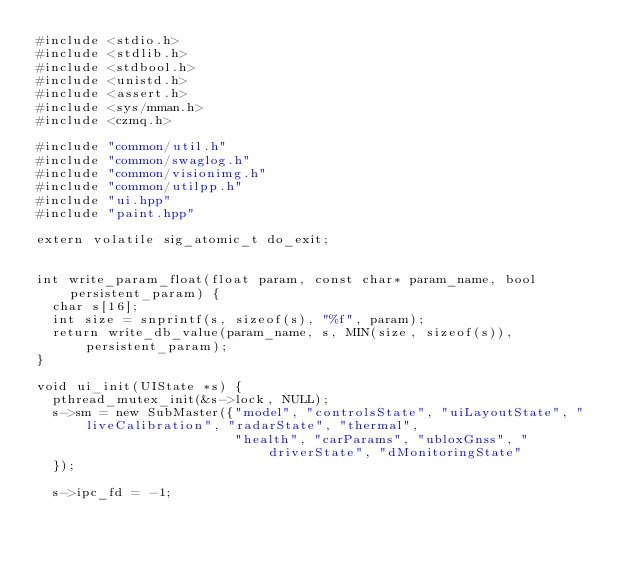<code> <loc_0><loc_0><loc_500><loc_500><_C++_>#include <stdio.h>
#include <stdlib.h>
#include <stdbool.h>
#include <unistd.h>
#include <assert.h>
#include <sys/mman.h>
#include <czmq.h>

#include "common/util.h"
#include "common/swaglog.h"
#include "common/visionimg.h"
#include "common/utilpp.h"
#include "ui.hpp"
#include "paint.hpp"

extern volatile sig_atomic_t do_exit;


int write_param_float(float param, const char* param_name, bool persistent_param) {
  char s[16];
  int size = snprintf(s, sizeof(s), "%f", param);
  return write_db_value(param_name, s, MIN(size, sizeof(s)), persistent_param);
}

void ui_init(UIState *s) {
  pthread_mutex_init(&s->lock, NULL);
  s->sm = new SubMaster({"model", "controlsState", "uiLayoutState", "liveCalibration", "radarState", "thermal",
                         "health", "carParams", "ubloxGnss", "driverState", "dMonitoringState"
  });

  s->ipc_fd = -1;</code> 